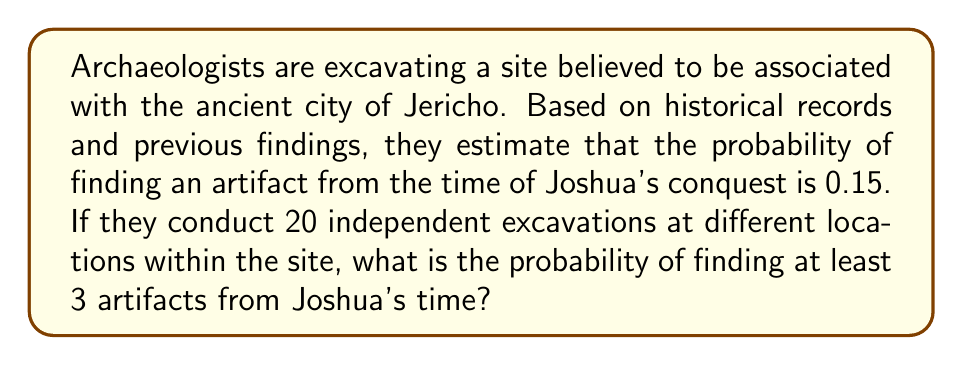Solve this math problem. To solve this problem, we can use the binomial probability distribution:

1) Let X be the number of successful excavations (finding an artifact from Joshua's time).
2) We have:
   n = 20 (number of excavations)
   p = 0.15 (probability of success for each excavation)
   We want P(X ≥ 3)

3) We can calculate this as 1 minus the probability of finding 0, 1, or 2 artifacts:
   P(X ≥ 3) = 1 - [P(X = 0) + P(X = 1) + P(X = 2)]

4) The binomial probability formula is:
   $$P(X = k) = \binom{n}{k} p^k (1-p)^{n-k}$$

5) Let's calculate each term:
   P(X = 0) = $$\binom{20}{0} 0.15^0 (1-0.15)^{20} = 0.0388$$
   P(X = 1) = $$\binom{20}{1} 0.15^1 (1-0.15)^{19} = 0.1368$$
   P(X = 2) = $$\binom{20}{2} 0.15^2 (1-0.15)^{18} = 0.2293$$

6) Now we can complete our calculation:
   P(X ≥ 3) = 1 - (0.0388 + 0.1368 + 0.2293) = 1 - 0.4049 = 0.5951

7) Therefore, the probability of finding at least 3 artifacts from Joshua's time is approximately 0.5951 or 59.51%.
Answer: 0.5951 